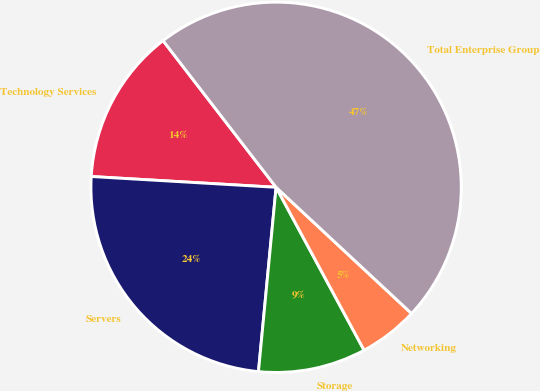<chart> <loc_0><loc_0><loc_500><loc_500><pie_chart><fcel>Technology Services<fcel>Servers<fcel>Storage<fcel>Networking<fcel>Total Enterprise Group<nl><fcel>13.62%<fcel>24.41%<fcel>9.4%<fcel>5.18%<fcel>47.39%<nl></chart> 